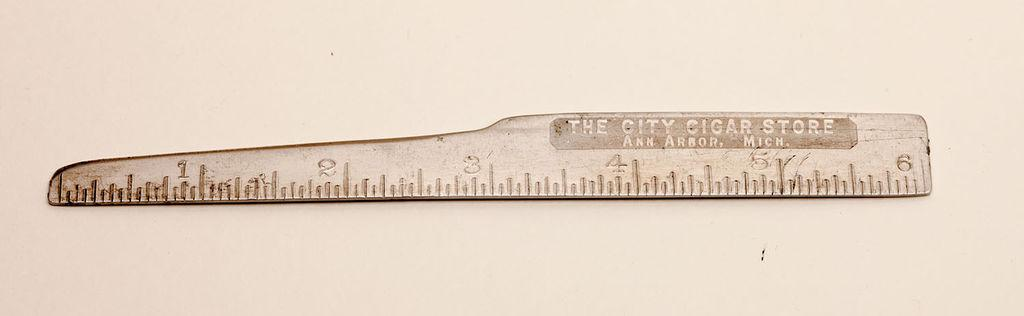<image>
Render a clear and concise summary of the photo. an old wooden broken ruler for The City Car Store 